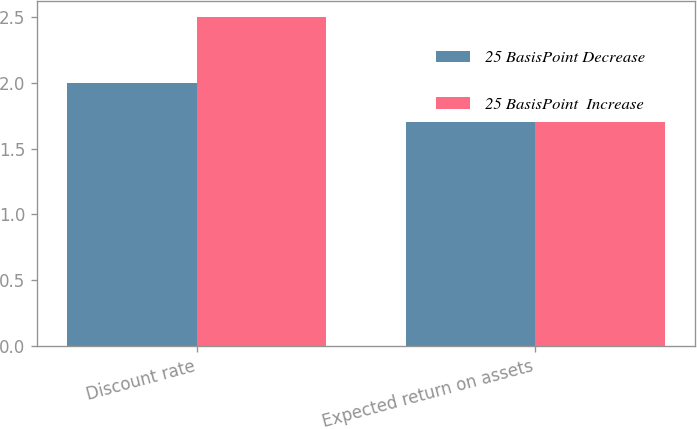Convert chart. <chart><loc_0><loc_0><loc_500><loc_500><stacked_bar_chart><ecel><fcel>Discount rate<fcel>Expected return on assets<nl><fcel>25 BasisPoint Decrease<fcel>2<fcel>1.7<nl><fcel>25 BasisPoint  Increase<fcel>2.5<fcel>1.7<nl></chart> 